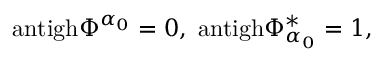<formula> <loc_0><loc_0><loc_500><loc_500>a n t i g h \Phi ^ { \alpha _ { 0 } } = 0 , \, a n t i g h \Phi _ { \alpha _ { 0 } } ^ { * } = 1 , \,</formula> 